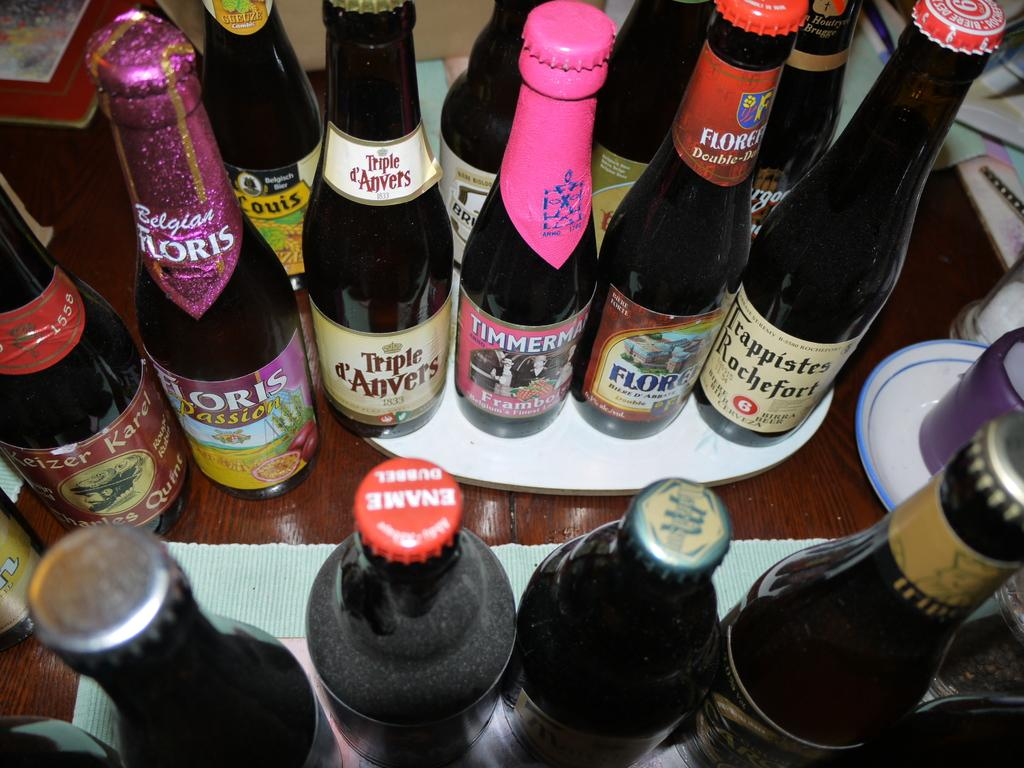What is located in the center of the image? There is a table in the middle of the image. What objects are placed on the table? There are bottles on the table. What type of shoe is visible on the table in the image? There is no shoe present on the table in the image. 